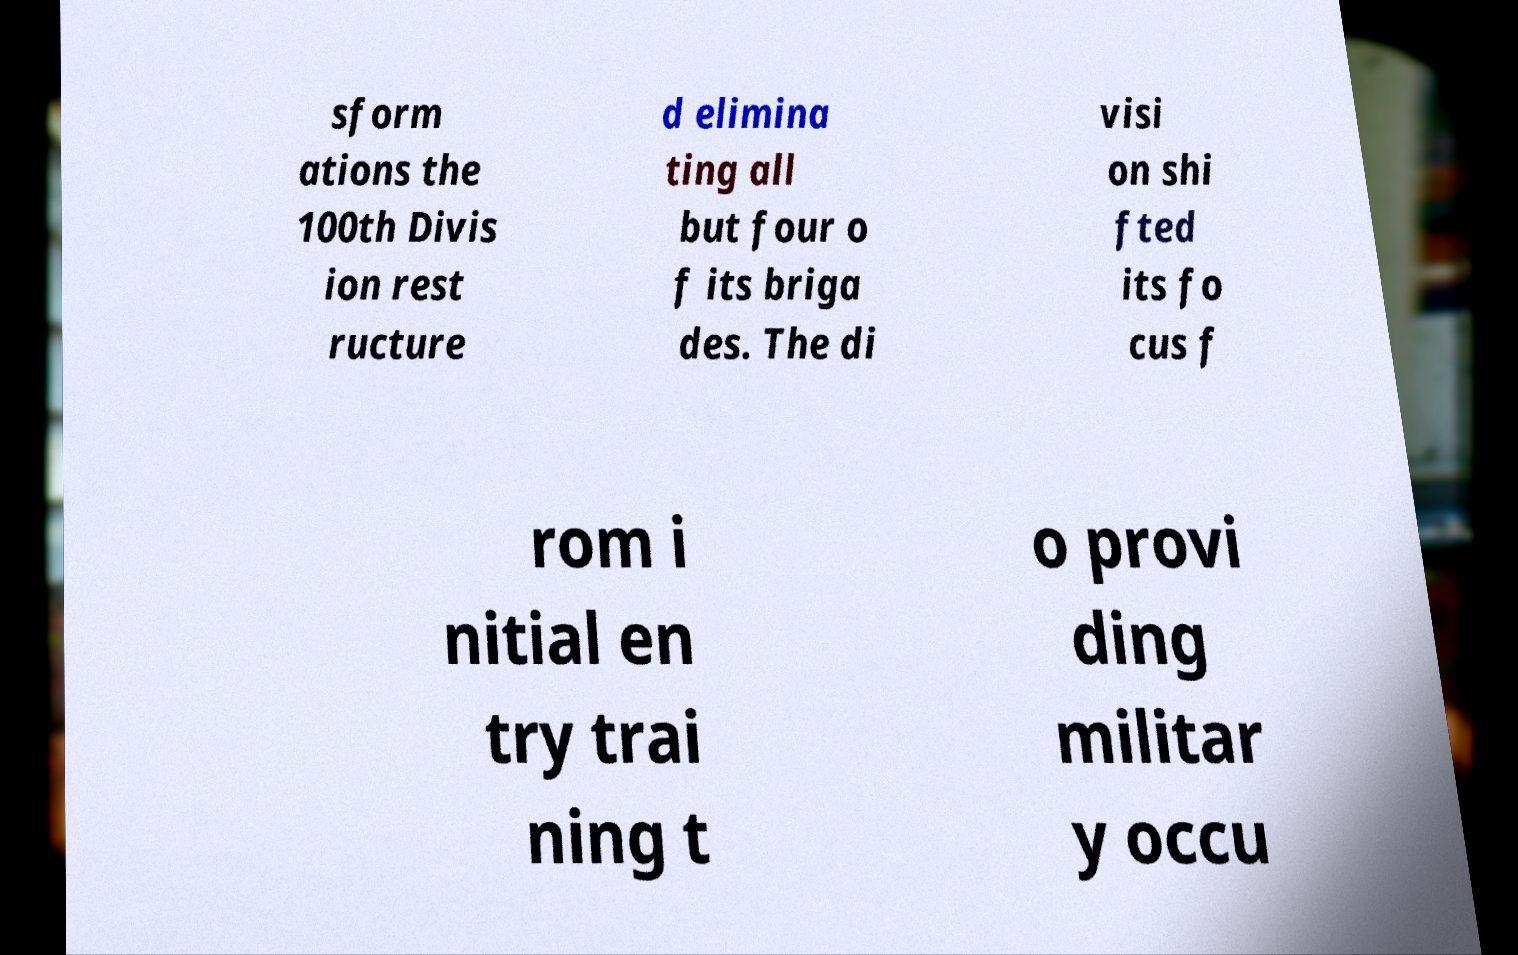Please read and relay the text visible in this image. What does it say? sform ations the 100th Divis ion rest ructure d elimina ting all but four o f its briga des. The di visi on shi fted its fo cus f rom i nitial en try trai ning t o provi ding militar y occu 